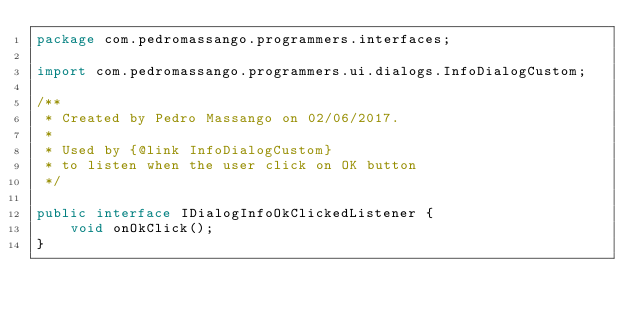<code> <loc_0><loc_0><loc_500><loc_500><_Java_>package com.pedromassango.programmers.interfaces;

import com.pedromassango.programmers.ui.dialogs.InfoDialogCustom;

/**
 * Created by Pedro Massango on 02/06/2017.
 *
 * Used by {@link InfoDialogCustom}
 * to listen when the user click on OK button
 */

public interface IDialogInfoOkClickedListener {
    void onOkClick();
}
</code> 